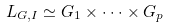Convert formula to latex. <formula><loc_0><loc_0><loc_500><loc_500>L _ { G , I } \simeq G _ { 1 } \times \cdot \cdot \cdot \times G _ { p }</formula> 